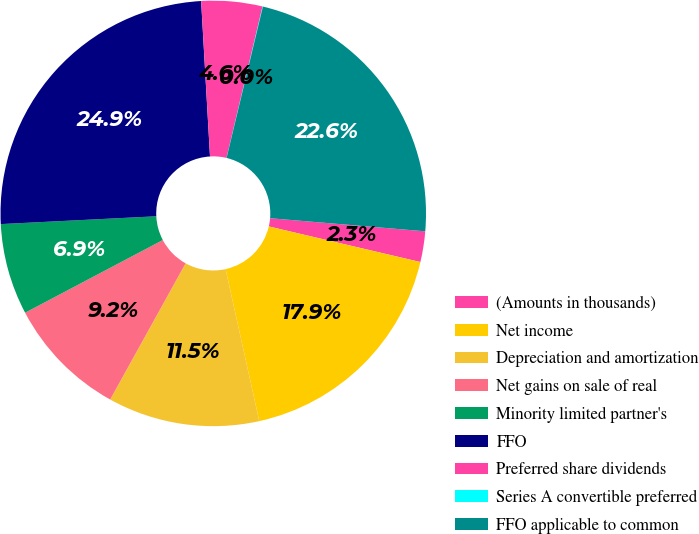Convert chart to OTSL. <chart><loc_0><loc_0><loc_500><loc_500><pie_chart><fcel>(Amounts in thousands)<fcel>Net income<fcel>Depreciation and amortization<fcel>Net gains on sale of real<fcel>Minority limited partner's<fcel>FFO<fcel>Preferred share dividends<fcel>Series A convertible preferred<fcel>FFO applicable to common<nl><fcel>2.33%<fcel>17.86%<fcel>11.52%<fcel>9.22%<fcel>6.93%<fcel>24.89%<fcel>4.63%<fcel>0.03%<fcel>22.59%<nl></chart> 